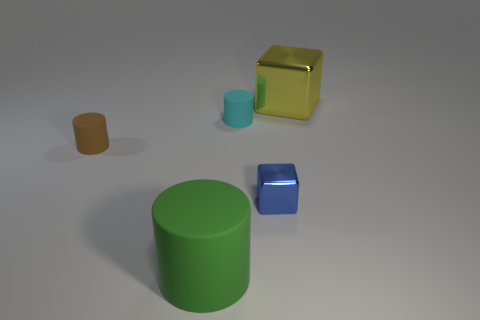The blue shiny object that is the same size as the cyan object is what shape?
Give a very brief answer. Cube. Does the tiny thing that is to the right of the tiny cyan thing have the same shape as the brown thing?
Offer a very short reply. No. There is a metallic cube behind the metallic thing in front of the big object right of the blue cube; what is its color?
Make the answer very short. Yellow. Does the blue metallic block have the same size as the cyan cylinder?
Provide a succinct answer. Yes. What number of objects are either shiny cubes that are behind the blue metal cube or small gray cylinders?
Your answer should be compact. 1. Does the brown matte object have the same shape as the big yellow shiny thing?
Offer a very short reply. No. What number of other objects are the same size as the yellow block?
Make the answer very short. 1. The big metal cube has what color?
Your response must be concise. Yellow. How many tiny objects are shiny objects or cyan matte things?
Make the answer very short. 2. There is a matte cylinder that is to the right of the large green cylinder; is its size the same as the yellow cube on the right side of the large matte thing?
Ensure brevity in your answer.  No. 